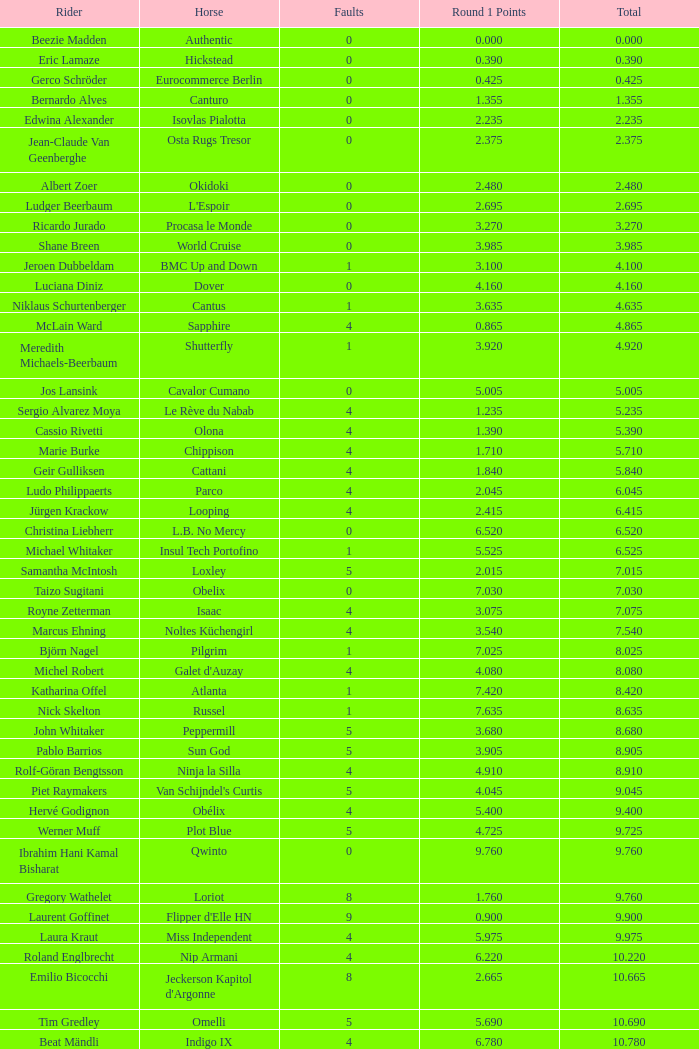Reveal the rider who obtained Manuel Fernandez Saro. 